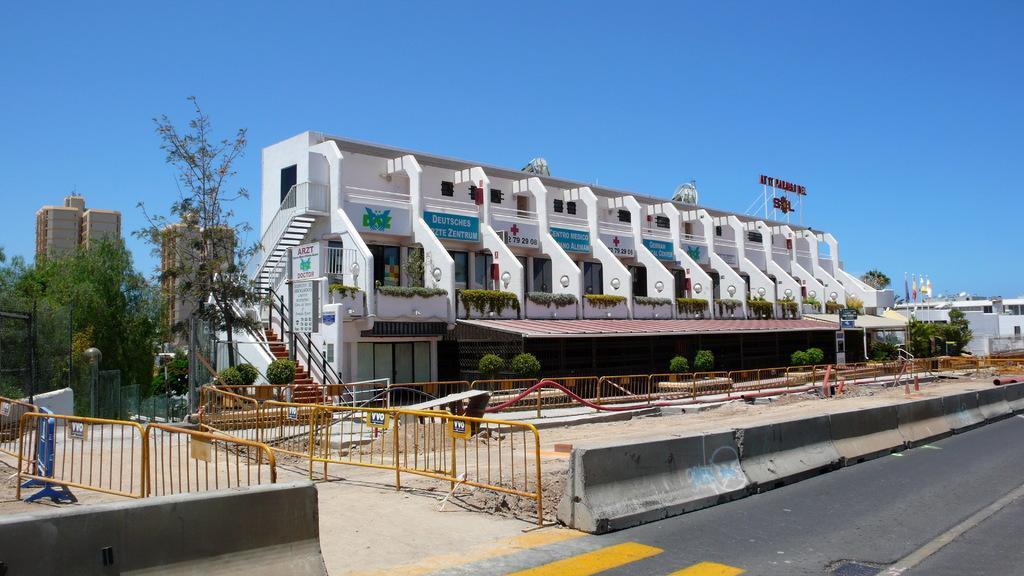Could you give a brief overview of what you see in this image? In this image we can see few buildings. In front of the building we can see a group of barriers, houseplants and a road. Beside the building we can see a group of trees and fencing. At the top we can see the sky. On the building we can see few boards. 